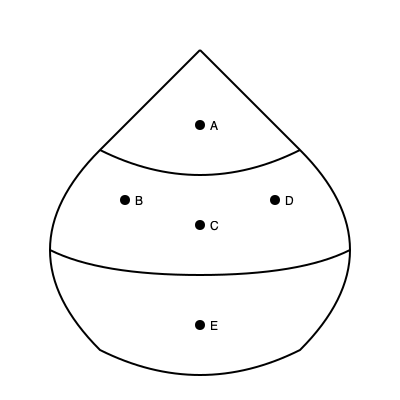Identify the parts of this 16th-century French hennin headdress:
A) The pointed tip
B) The side veil attachment point
C) The forehead band
D) The wire frame support
E) The chin strap connection

Which part, typically made of silk or fine linen, was used to cover the wearer's hair and neck, extending from points B? To answer this question, let's break down the parts of the hennin headdress:

1. Part A is the pointed tip, which gives the hennin its characteristic conical shape.
2. Part B is the side veil attachment point, where additional fabric would be connected to the main structure.
3. Part C is the forehead band, which sits across the wearer's forehead to secure the headdress.
4. Part D is the wire frame support, providing structure to the entire hennin.
5. Part E is the chin strap connection, used to fasten the headdress under the wearer's chin.

The question asks about the part extending from points B, which are the side veil attachment points. In a 16th-century French hennin, these points were used to attach a veil that would cover the wearer's hair and neck. This veil was typically made of silk or fine linen, chosen for their lightweight and luxurious qualities.

The veil served multiple purposes:
1. It covered the hair, which was often shaved or plucked at the forehead to achieve a high hairline, fashionable at the time.
2. It provided modesty, as married women were expected to cover their hair in public.
3. It added to the overall dramatic silhouette of the headdress, often flowing down the back or sides.

This side veil, attached at points B and flowing downward, was a crucial element of the hennin, distinguishing it from other cone-shaped headdresses of the period.
Answer: Side veil 